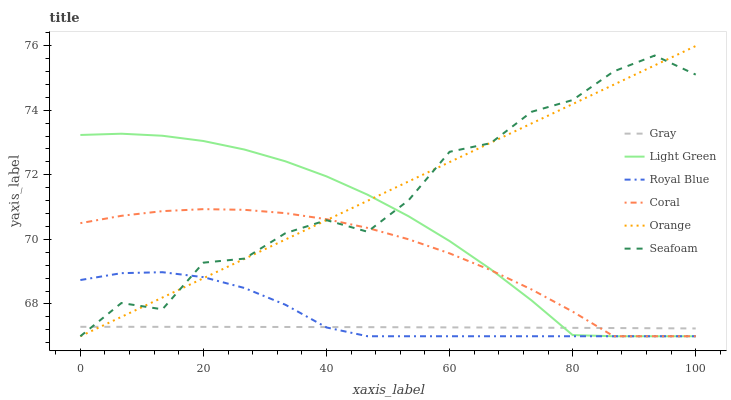Does Gray have the minimum area under the curve?
Answer yes or no. Yes. Does Seafoam have the maximum area under the curve?
Answer yes or no. Yes. Does Coral have the minimum area under the curve?
Answer yes or no. No. Does Coral have the maximum area under the curve?
Answer yes or no. No. Is Orange the smoothest?
Answer yes or no. Yes. Is Seafoam the roughest?
Answer yes or no. Yes. Is Coral the smoothest?
Answer yes or no. No. Is Coral the roughest?
Answer yes or no. No. Does Coral have the lowest value?
Answer yes or no. Yes. Does Orange have the highest value?
Answer yes or no. Yes. Does Coral have the highest value?
Answer yes or no. No. Does Light Green intersect Orange?
Answer yes or no. Yes. Is Light Green less than Orange?
Answer yes or no. No. Is Light Green greater than Orange?
Answer yes or no. No. 